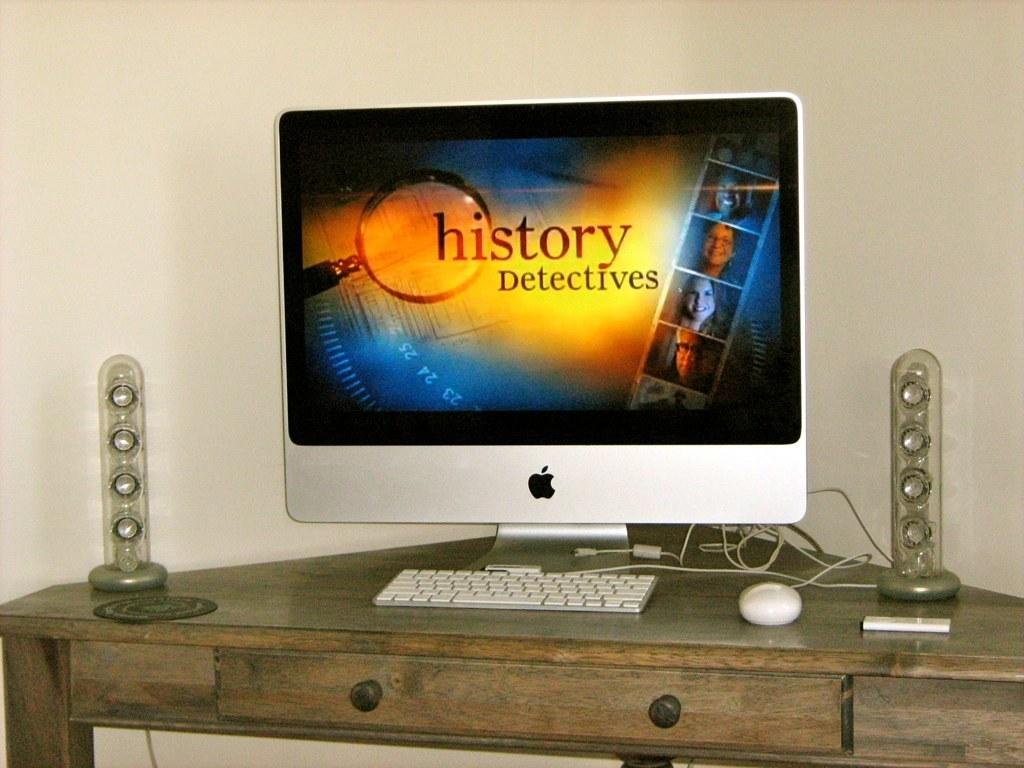What type of computer monitor is in the image? There is an Apple monitor in the image. What device is used for typing in the image? There is a keyboard in the image. What connects the devices in the image? Cables are visible in the image. What is used for controlling the cursor on the screen? There is a mouse in the image. What is a small storage device present in the image? A pen-drive is present in the image. What type of speakers are visible in the image? Soundsticks are visible in the image. What is used for the mouse to glide smoothly? There is a mouse pad in the image. What object is on the table in the image? There is an object on the table in the image. What is visible in the background of the image? There is a wall in the background of the image. What type of cherries are hanging from the wall in the image? There are no cherries present in the image; it features a wall in the background. What type of fan is used to cool the computer in the image? There is no fan present in the image; it only shows computer equipment and a wall in the background. 